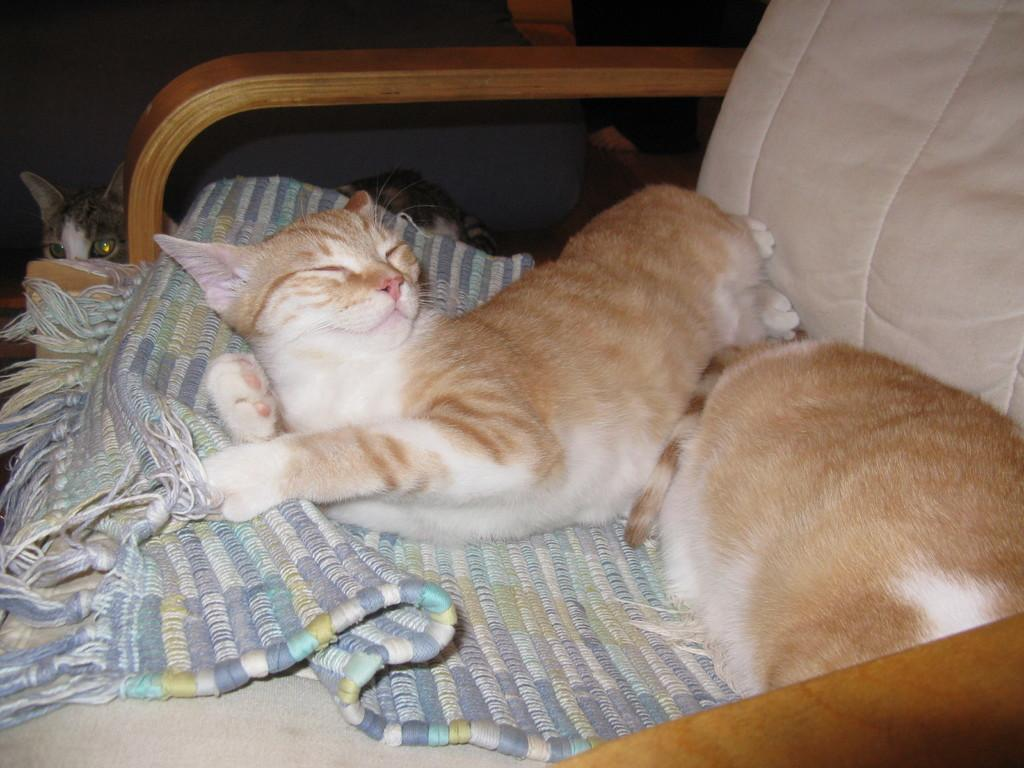What animals are visible in the image? There are three cats visible in the image. Where are the cats located in the image? Two cats are sleeping on the chair, and another cat is at the back of the chair. What is the purpose of the mat in the image? The purpose of the mat is not specified in the image, but it could be for the cats to sit or lie on. What can be seen in the background of the image? The background of the image includes a wall. What type of wave can be seen crashing on the shore in the image? There is no wave or shore present in the image; it features cats on a chair and a mat. 